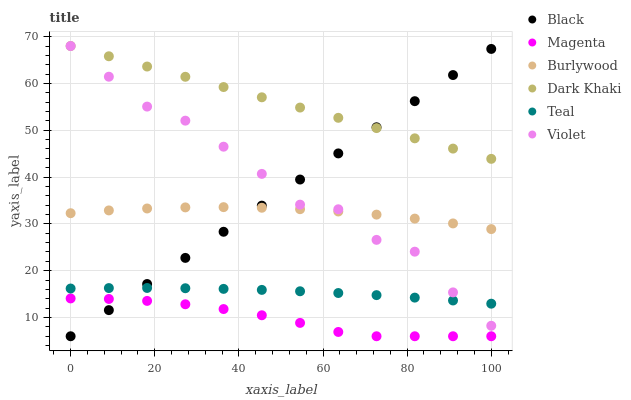Does Magenta have the minimum area under the curve?
Answer yes or no. Yes. Does Dark Khaki have the maximum area under the curve?
Answer yes or no. Yes. Does Black have the minimum area under the curve?
Answer yes or no. No. Does Black have the maximum area under the curve?
Answer yes or no. No. Is Black the smoothest?
Answer yes or no. Yes. Is Violet the roughest?
Answer yes or no. Yes. Is Dark Khaki the smoothest?
Answer yes or no. No. Is Dark Khaki the roughest?
Answer yes or no. No. Does Black have the lowest value?
Answer yes or no. Yes. Does Dark Khaki have the lowest value?
Answer yes or no. No. Does Violet have the highest value?
Answer yes or no. Yes. Does Black have the highest value?
Answer yes or no. No. Is Burlywood less than Dark Khaki?
Answer yes or no. Yes. Is Burlywood greater than Teal?
Answer yes or no. Yes. Does Violet intersect Teal?
Answer yes or no. Yes. Is Violet less than Teal?
Answer yes or no. No. Is Violet greater than Teal?
Answer yes or no. No. Does Burlywood intersect Dark Khaki?
Answer yes or no. No. 